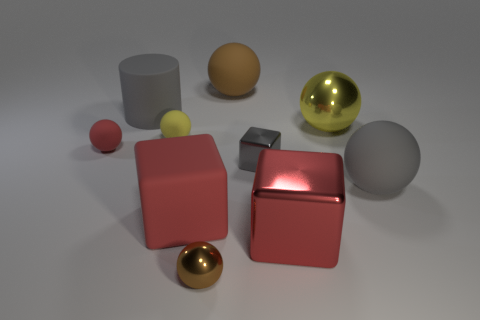Are there more gray cubes than red metallic balls?
Offer a terse response. Yes. What number of things are brown things that are behind the brown shiny sphere or matte blocks?
Keep it short and to the point. 2. What number of big metallic cubes are on the right side of the tiny shiny thing behind the gray sphere?
Keep it short and to the point. 1. How big is the gray rubber thing that is on the left side of the brown object that is behind the big metal thing in front of the red rubber cube?
Provide a short and direct response. Large. There is a rubber cylinder that is behind the small gray metal block; is its color the same as the big shiny cube?
Offer a very short reply. No. What size is the other red object that is the same shape as the big red metal thing?
Offer a terse response. Large. What number of objects are either things that are in front of the large brown thing or red blocks that are right of the big brown rubber sphere?
Make the answer very short. 9. The big gray matte thing that is on the left side of the large red object that is to the right of the tiny brown object is what shape?
Offer a very short reply. Cylinder. Is there any other thing that has the same color as the small shiny sphere?
Provide a short and direct response. Yes. Is there anything else that is the same size as the matte cylinder?
Your answer should be compact. Yes. 